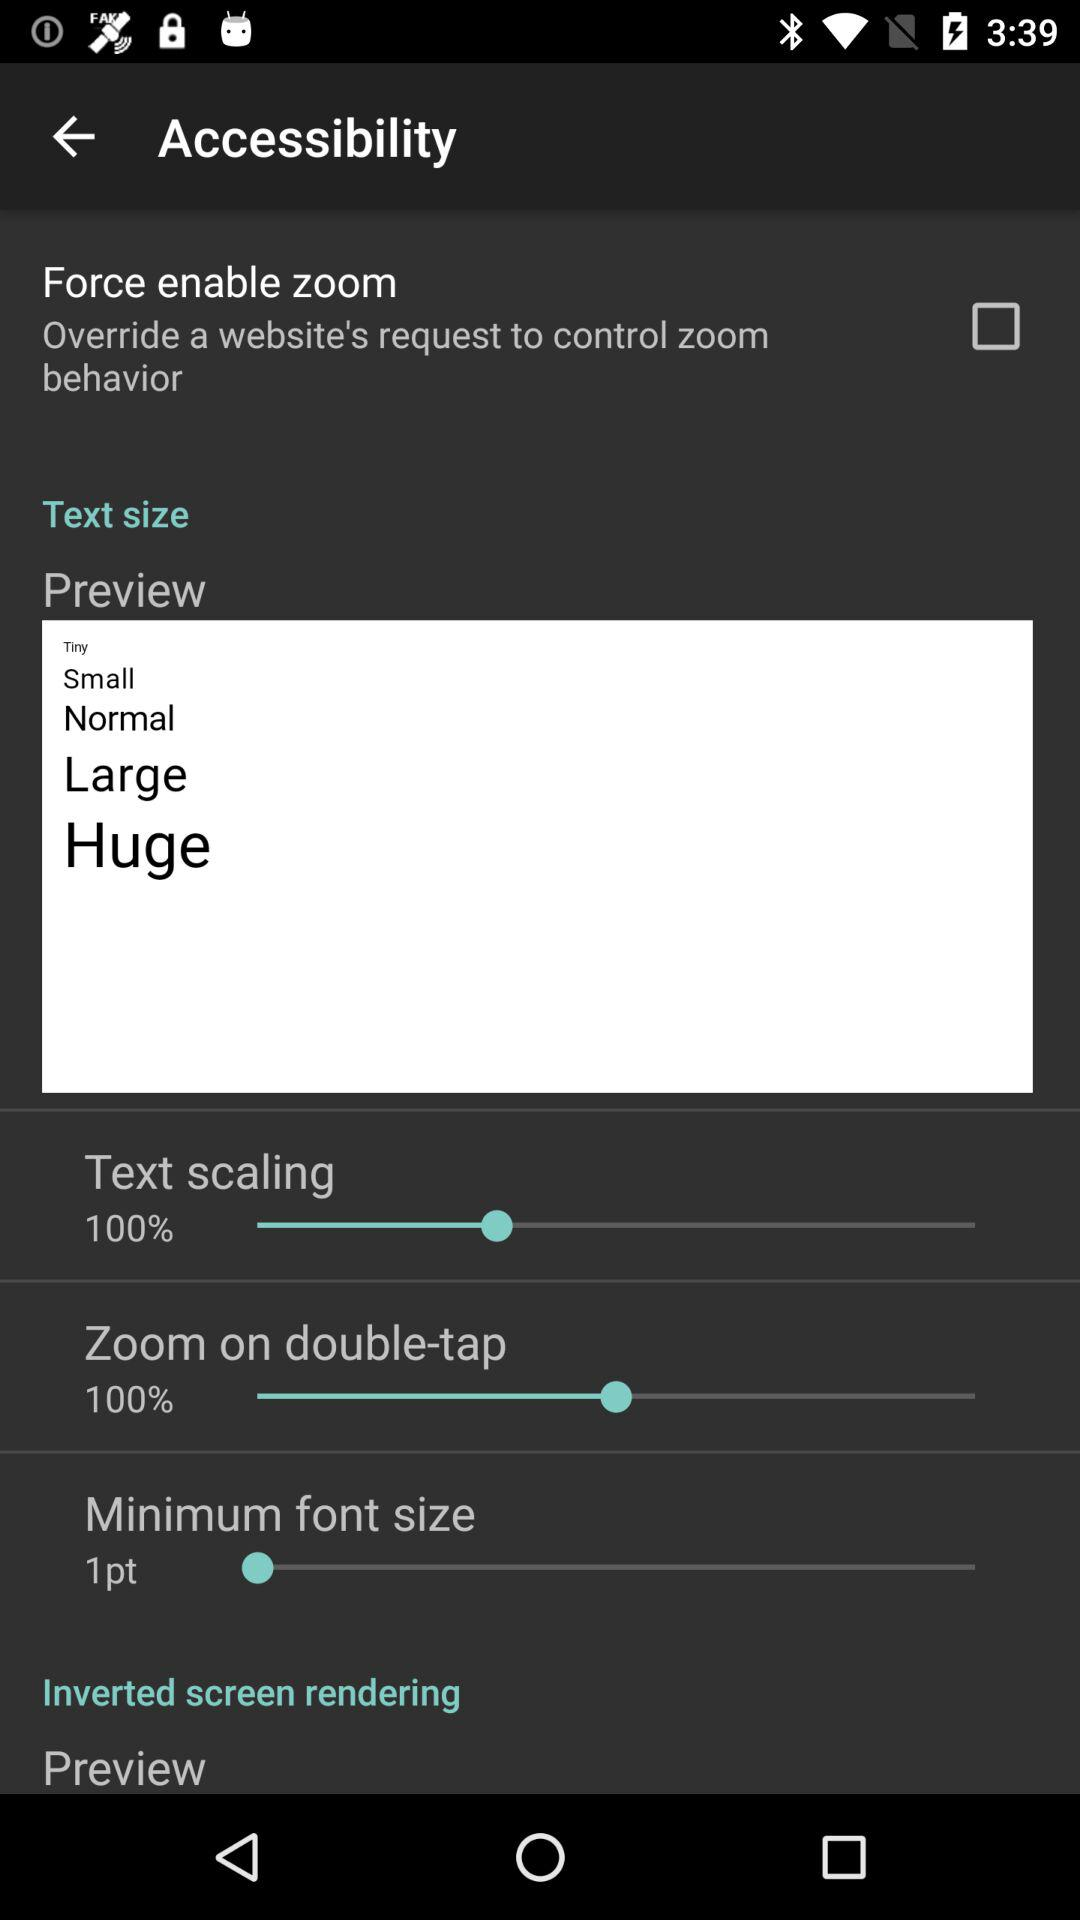What is the status of "Force enable zoom"? The status is "off". 